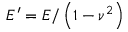<formula> <loc_0><loc_0><loc_500><loc_500>E ^ { \prime } = E / \left ( 1 - \nu ^ { 2 } \right )</formula> 